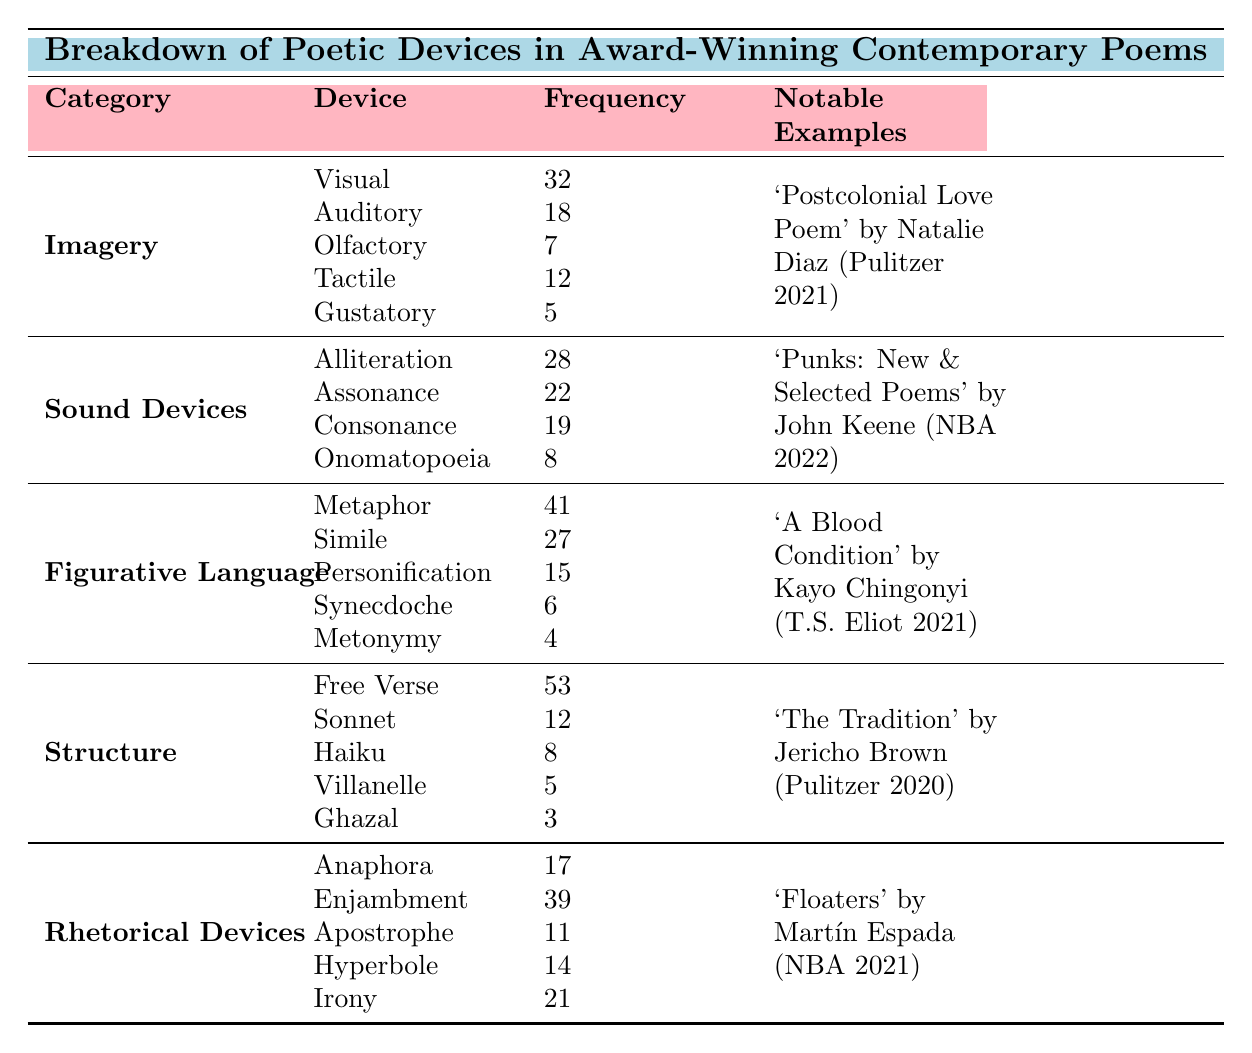What is the most frequently used poetic device in contemporary award-winning poems? From the table, the most frequently mentioned poetic device is "Free Verse," which occurs 53 times.
Answer: Free Verse How many different types of imagery are listed in the table? The table lists five types of imagery: Visual, Auditory, Olfactory, Tactile, and Gustatory.
Answer: Five Which figurative language device is used most frequently? The most frequently used figurative language device is "Metaphor," with a frequency of 41 occurrences.
Answer: Metaphor What is the predominant device used in the Pulitzer Prize-winning collection 'Postcolonial Love Poem'? According to the table, the predominant device used in 'Postcolonial Love Poem' is "Imagery."
Answer: Imagery How many total instances of Sound Devices are present? By adding the frequencies of each sound device (Alliteration 28, Assonance 22, Consonance 19, Onomatopoeia 8), we get a total of 77.
Answer: 77 Which award-winning collection has the lowest frequency of devices mentioned, and how many? The collection 'Ghazal' has the lowest frequency of mentioned devices, with only 3 occurrences.
Answer: 'Ghazal', 3 Which year did the highest frequency of imagery appear in contemporary award-winning poems, and what collection was it from? The 'Postcolonial Love Poem' from 2021 has a notable use of "Imagery" with a frequency of 18 instances.
Answer: 2021, 'Postcolonial Love Poem' How does the frequency of "Free Verse" compare to that of "Sonnet"? The frequency of "Free Verse" is 53, while "Sonnet" has a frequency of 12; thus, "Free Verse" is used significantly more than "Sonnet."
Answer: 53 > 12 What is the total count of Rhetorical Devices in the table? By adding the counts of each rhetorical device (Anaphora 17, Enjambment 39, Apostrophe 11, Hyperbole 14, Irony 21), the total is 102.
Answer: 102 Which of the collections listed has the most notable use of Anaphora and in which year? The collection 'Floaters' by Martín Espada, which won the National Book Award in 2021, has the most notable use of Anaphora.
Answer: 'Floaters', 2021 